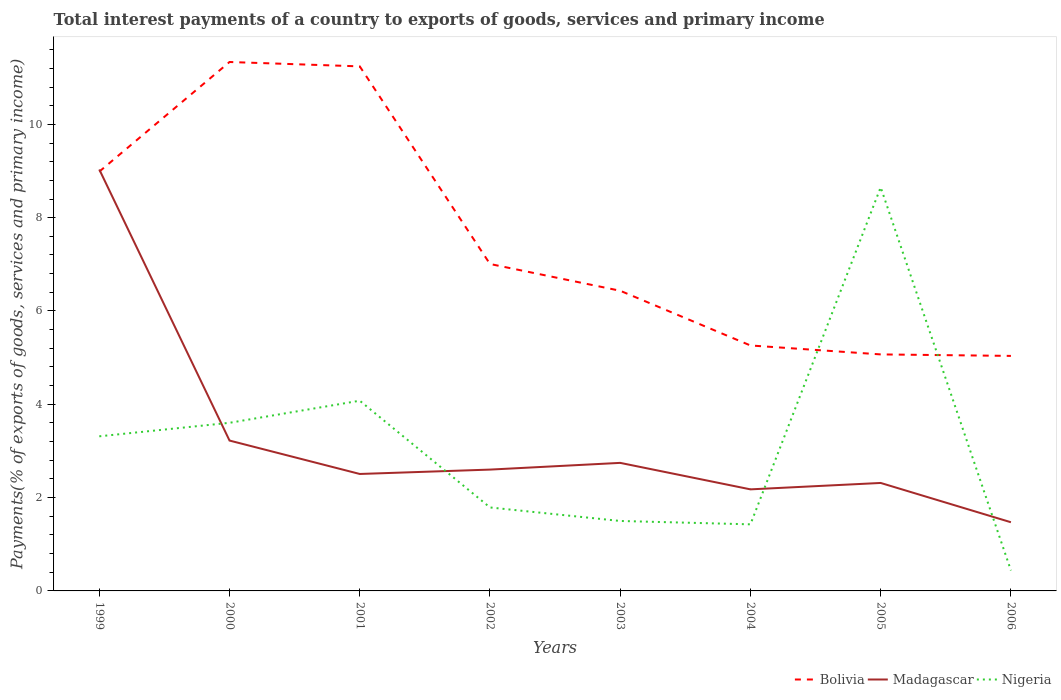Does the line corresponding to Bolivia intersect with the line corresponding to Nigeria?
Your answer should be very brief. Yes. Is the number of lines equal to the number of legend labels?
Your answer should be very brief. Yes. Across all years, what is the maximum total interest payments in Bolivia?
Keep it short and to the point. 5.04. In which year was the total interest payments in Bolivia maximum?
Offer a terse response. 2006. What is the total total interest payments in Bolivia in the graph?
Offer a very short reply. 1.75. What is the difference between the highest and the second highest total interest payments in Bolivia?
Offer a very short reply. 6.3. Is the total interest payments in Nigeria strictly greater than the total interest payments in Madagascar over the years?
Ensure brevity in your answer.  No. What is the difference between two consecutive major ticks on the Y-axis?
Offer a terse response. 2. Are the values on the major ticks of Y-axis written in scientific E-notation?
Make the answer very short. No. Does the graph contain any zero values?
Ensure brevity in your answer.  No. Does the graph contain grids?
Offer a very short reply. No. What is the title of the graph?
Your answer should be compact. Total interest payments of a country to exports of goods, services and primary income. Does "Macedonia" appear as one of the legend labels in the graph?
Provide a short and direct response. No. What is the label or title of the Y-axis?
Offer a very short reply. Payments(% of exports of goods, services and primary income). What is the Payments(% of exports of goods, services and primary income) in Bolivia in 1999?
Your response must be concise. 8.99. What is the Payments(% of exports of goods, services and primary income) of Madagascar in 1999?
Your response must be concise. 9.03. What is the Payments(% of exports of goods, services and primary income) of Nigeria in 1999?
Ensure brevity in your answer.  3.31. What is the Payments(% of exports of goods, services and primary income) in Bolivia in 2000?
Make the answer very short. 11.34. What is the Payments(% of exports of goods, services and primary income) of Madagascar in 2000?
Offer a very short reply. 3.22. What is the Payments(% of exports of goods, services and primary income) of Nigeria in 2000?
Make the answer very short. 3.6. What is the Payments(% of exports of goods, services and primary income) in Bolivia in 2001?
Offer a very short reply. 11.24. What is the Payments(% of exports of goods, services and primary income) of Madagascar in 2001?
Your response must be concise. 2.51. What is the Payments(% of exports of goods, services and primary income) in Nigeria in 2001?
Make the answer very short. 4.08. What is the Payments(% of exports of goods, services and primary income) in Bolivia in 2002?
Offer a very short reply. 7.01. What is the Payments(% of exports of goods, services and primary income) in Madagascar in 2002?
Ensure brevity in your answer.  2.6. What is the Payments(% of exports of goods, services and primary income) of Nigeria in 2002?
Your answer should be compact. 1.79. What is the Payments(% of exports of goods, services and primary income) in Bolivia in 2003?
Make the answer very short. 6.43. What is the Payments(% of exports of goods, services and primary income) of Madagascar in 2003?
Keep it short and to the point. 2.74. What is the Payments(% of exports of goods, services and primary income) in Nigeria in 2003?
Offer a terse response. 1.5. What is the Payments(% of exports of goods, services and primary income) in Bolivia in 2004?
Your response must be concise. 5.26. What is the Payments(% of exports of goods, services and primary income) of Madagascar in 2004?
Provide a succinct answer. 2.18. What is the Payments(% of exports of goods, services and primary income) of Nigeria in 2004?
Your response must be concise. 1.43. What is the Payments(% of exports of goods, services and primary income) of Bolivia in 2005?
Give a very brief answer. 5.07. What is the Payments(% of exports of goods, services and primary income) in Madagascar in 2005?
Your answer should be compact. 2.31. What is the Payments(% of exports of goods, services and primary income) of Nigeria in 2005?
Your answer should be compact. 8.65. What is the Payments(% of exports of goods, services and primary income) of Bolivia in 2006?
Ensure brevity in your answer.  5.04. What is the Payments(% of exports of goods, services and primary income) in Madagascar in 2006?
Offer a very short reply. 1.47. What is the Payments(% of exports of goods, services and primary income) of Nigeria in 2006?
Ensure brevity in your answer.  0.44. Across all years, what is the maximum Payments(% of exports of goods, services and primary income) in Bolivia?
Make the answer very short. 11.34. Across all years, what is the maximum Payments(% of exports of goods, services and primary income) in Madagascar?
Your answer should be very brief. 9.03. Across all years, what is the maximum Payments(% of exports of goods, services and primary income) of Nigeria?
Offer a very short reply. 8.65. Across all years, what is the minimum Payments(% of exports of goods, services and primary income) in Bolivia?
Offer a very short reply. 5.04. Across all years, what is the minimum Payments(% of exports of goods, services and primary income) in Madagascar?
Your answer should be compact. 1.47. Across all years, what is the minimum Payments(% of exports of goods, services and primary income) in Nigeria?
Offer a very short reply. 0.44. What is the total Payments(% of exports of goods, services and primary income) in Bolivia in the graph?
Make the answer very short. 60.37. What is the total Payments(% of exports of goods, services and primary income) in Madagascar in the graph?
Provide a short and direct response. 26.07. What is the total Payments(% of exports of goods, services and primary income) in Nigeria in the graph?
Provide a short and direct response. 24.8. What is the difference between the Payments(% of exports of goods, services and primary income) of Bolivia in 1999 and that in 2000?
Keep it short and to the point. -2.35. What is the difference between the Payments(% of exports of goods, services and primary income) of Madagascar in 1999 and that in 2000?
Offer a very short reply. 5.81. What is the difference between the Payments(% of exports of goods, services and primary income) in Nigeria in 1999 and that in 2000?
Ensure brevity in your answer.  -0.29. What is the difference between the Payments(% of exports of goods, services and primary income) in Bolivia in 1999 and that in 2001?
Provide a succinct answer. -2.26. What is the difference between the Payments(% of exports of goods, services and primary income) of Madagascar in 1999 and that in 2001?
Give a very brief answer. 6.53. What is the difference between the Payments(% of exports of goods, services and primary income) in Nigeria in 1999 and that in 2001?
Provide a succinct answer. -0.76. What is the difference between the Payments(% of exports of goods, services and primary income) of Bolivia in 1999 and that in 2002?
Offer a terse response. 1.98. What is the difference between the Payments(% of exports of goods, services and primary income) in Madagascar in 1999 and that in 2002?
Offer a very short reply. 6.43. What is the difference between the Payments(% of exports of goods, services and primary income) in Nigeria in 1999 and that in 2002?
Offer a terse response. 1.52. What is the difference between the Payments(% of exports of goods, services and primary income) of Bolivia in 1999 and that in 2003?
Offer a terse response. 2.55. What is the difference between the Payments(% of exports of goods, services and primary income) of Madagascar in 1999 and that in 2003?
Ensure brevity in your answer.  6.29. What is the difference between the Payments(% of exports of goods, services and primary income) of Nigeria in 1999 and that in 2003?
Provide a short and direct response. 1.81. What is the difference between the Payments(% of exports of goods, services and primary income) of Bolivia in 1999 and that in 2004?
Ensure brevity in your answer.  3.73. What is the difference between the Payments(% of exports of goods, services and primary income) in Madagascar in 1999 and that in 2004?
Provide a succinct answer. 6.86. What is the difference between the Payments(% of exports of goods, services and primary income) of Nigeria in 1999 and that in 2004?
Your answer should be very brief. 1.89. What is the difference between the Payments(% of exports of goods, services and primary income) of Bolivia in 1999 and that in 2005?
Provide a succinct answer. 3.92. What is the difference between the Payments(% of exports of goods, services and primary income) of Madagascar in 1999 and that in 2005?
Make the answer very short. 6.72. What is the difference between the Payments(% of exports of goods, services and primary income) in Nigeria in 1999 and that in 2005?
Provide a short and direct response. -5.34. What is the difference between the Payments(% of exports of goods, services and primary income) in Bolivia in 1999 and that in 2006?
Keep it short and to the point. 3.95. What is the difference between the Payments(% of exports of goods, services and primary income) in Madagascar in 1999 and that in 2006?
Your answer should be very brief. 7.56. What is the difference between the Payments(% of exports of goods, services and primary income) of Nigeria in 1999 and that in 2006?
Keep it short and to the point. 2.87. What is the difference between the Payments(% of exports of goods, services and primary income) in Bolivia in 2000 and that in 2001?
Offer a very short reply. 0.09. What is the difference between the Payments(% of exports of goods, services and primary income) in Madagascar in 2000 and that in 2001?
Your answer should be very brief. 0.72. What is the difference between the Payments(% of exports of goods, services and primary income) of Nigeria in 2000 and that in 2001?
Make the answer very short. -0.47. What is the difference between the Payments(% of exports of goods, services and primary income) of Bolivia in 2000 and that in 2002?
Your answer should be compact. 4.33. What is the difference between the Payments(% of exports of goods, services and primary income) in Madagascar in 2000 and that in 2002?
Ensure brevity in your answer.  0.62. What is the difference between the Payments(% of exports of goods, services and primary income) of Nigeria in 2000 and that in 2002?
Make the answer very short. 1.81. What is the difference between the Payments(% of exports of goods, services and primary income) of Bolivia in 2000 and that in 2003?
Your answer should be very brief. 4.9. What is the difference between the Payments(% of exports of goods, services and primary income) of Madagascar in 2000 and that in 2003?
Ensure brevity in your answer.  0.48. What is the difference between the Payments(% of exports of goods, services and primary income) of Nigeria in 2000 and that in 2003?
Offer a very short reply. 2.1. What is the difference between the Payments(% of exports of goods, services and primary income) of Bolivia in 2000 and that in 2004?
Provide a short and direct response. 6.08. What is the difference between the Payments(% of exports of goods, services and primary income) in Madagascar in 2000 and that in 2004?
Offer a terse response. 1.05. What is the difference between the Payments(% of exports of goods, services and primary income) in Nigeria in 2000 and that in 2004?
Provide a succinct answer. 2.18. What is the difference between the Payments(% of exports of goods, services and primary income) of Bolivia in 2000 and that in 2005?
Ensure brevity in your answer.  6.27. What is the difference between the Payments(% of exports of goods, services and primary income) in Madagascar in 2000 and that in 2005?
Your answer should be compact. 0.91. What is the difference between the Payments(% of exports of goods, services and primary income) in Nigeria in 2000 and that in 2005?
Provide a succinct answer. -5.05. What is the difference between the Payments(% of exports of goods, services and primary income) in Bolivia in 2000 and that in 2006?
Your answer should be very brief. 6.3. What is the difference between the Payments(% of exports of goods, services and primary income) in Madagascar in 2000 and that in 2006?
Make the answer very short. 1.75. What is the difference between the Payments(% of exports of goods, services and primary income) of Nigeria in 2000 and that in 2006?
Your answer should be compact. 3.16. What is the difference between the Payments(% of exports of goods, services and primary income) of Bolivia in 2001 and that in 2002?
Give a very brief answer. 4.24. What is the difference between the Payments(% of exports of goods, services and primary income) in Madagascar in 2001 and that in 2002?
Provide a short and direct response. -0.09. What is the difference between the Payments(% of exports of goods, services and primary income) in Nigeria in 2001 and that in 2002?
Your response must be concise. 2.29. What is the difference between the Payments(% of exports of goods, services and primary income) in Bolivia in 2001 and that in 2003?
Keep it short and to the point. 4.81. What is the difference between the Payments(% of exports of goods, services and primary income) of Madagascar in 2001 and that in 2003?
Provide a short and direct response. -0.24. What is the difference between the Payments(% of exports of goods, services and primary income) of Nigeria in 2001 and that in 2003?
Your response must be concise. 2.58. What is the difference between the Payments(% of exports of goods, services and primary income) of Bolivia in 2001 and that in 2004?
Keep it short and to the point. 5.98. What is the difference between the Payments(% of exports of goods, services and primary income) in Madagascar in 2001 and that in 2004?
Provide a succinct answer. 0.33. What is the difference between the Payments(% of exports of goods, services and primary income) in Nigeria in 2001 and that in 2004?
Provide a succinct answer. 2.65. What is the difference between the Payments(% of exports of goods, services and primary income) of Bolivia in 2001 and that in 2005?
Your response must be concise. 6.17. What is the difference between the Payments(% of exports of goods, services and primary income) in Madagascar in 2001 and that in 2005?
Your answer should be compact. 0.19. What is the difference between the Payments(% of exports of goods, services and primary income) in Nigeria in 2001 and that in 2005?
Provide a short and direct response. -4.57. What is the difference between the Payments(% of exports of goods, services and primary income) in Bolivia in 2001 and that in 2006?
Ensure brevity in your answer.  6.21. What is the difference between the Payments(% of exports of goods, services and primary income) in Madagascar in 2001 and that in 2006?
Your answer should be very brief. 1.03. What is the difference between the Payments(% of exports of goods, services and primary income) of Nigeria in 2001 and that in 2006?
Your answer should be compact. 3.64. What is the difference between the Payments(% of exports of goods, services and primary income) of Bolivia in 2002 and that in 2003?
Your answer should be compact. 0.57. What is the difference between the Payments(% of exports of goods, services and primary income) of Madagascar in 2002 and that in 2003?
Keep it short and to the point. -0.14. What is the difference between the Payments(% of exports of goods, services and primary income) in Nigeria in 2002 and that in 2003?
Your answer should be compact. 0.29. What is the difference between the Payments(% of exports of goods, services and primary income) in Bolivia in 2002 and that in 2004?
Provide a short and direct response. 1.75. What is the difference between the Payments(% of exports of goods, services and primary income) of Madagascar in 2002 and that in 2004?
Keep it short and to the point. 0.42. What is the difference between the Payments(% of exports of goods, services and primary income) of Nigeria in 2002 and that in 2004?
Provide a short and direct response. 0.36. What is the difference between the Payments(% of exports of goods, services and primary income) in Bolivia in 2002 and that in 2005?
Offer a terse response. 1.94. What is the difference between the Payments(% of exports of goods, services and primary income) of Madagascar in 2002 and that in 2005?
Make the answer very short. 0.29. What is the difference between the Payments(% of exports of goods, services and primary income) in Nigeria in 2002 and that in 2005?
Your answer should be very brief. -6.86. What is the difference between the Payments(% of exports of goods, services and primary income) in Bolivia in 2002 and that in 2006?
Give a very brief answer. 1.97. What is the difference between the Payments(% of exports of goods, services and primary income) of Madagascar in 2002 and that in 2006?
Your answer should be very brief. 1.13. What is the difference between the Payments(% of exports of goods, services and primary income) in Nigeria in 2002 and that in 2006?
Give a very brief answer. 1.35. What is the difference between the Payments(% of exports of goods, services and primary income) in Bolivia in 2003 and that in 2004?
Your answer should be compact. 1.17. What is the difference between the Payments(% of exports of goods, services and primary income) of Madagascar in 2003 and that in 2004?
Ensure brevity in your answer.  0.57. What is the difference between the Payments(% of exports of goods, services and primary income) of Nigeria in 2003 and that in 2004?
Your response must be concise. 0.07. What is the difference between the Payments(% of exports of goods, services and primary income) in Bolivia in 2003 and that in 2005?
Keep it short and to the point. 1.36. What is the difference between the Payments(% of exports of goods, services and primary income) in Madagascar in 2003 and that in 2005?
Your response must be concise. 0.43. What is the difference between the Payments(% of exports of goods, services and primary income) of Nigeria in 2003 and that in 2005?
Your answer should be compact. -7.15. What is the difference between the Payments(% of exports of goods, services and primary income) of Bolivia in 2003 and that in 2006?
Your answer should be compact. 1.4. What is the difference between the Payments(% of exports of goods, services and primary income) of Madagascar in 2003 and that in 2006?
Make the answer very short. 1.27. What is the difference between the Payments(% of exports of goods, services and primary income) in Nigeria in 2003 and that in 2006?
Give a very brief answer. 1.06. What is the difference between the Payments(% of exports of goods, services and primary income) in Bolivia in 2004 and that in 2005?
Ensure brevity in your answer.  0.19. What is the difference between the Payments(% of exports of goods, services and primary income) of Madagascar in 2004 and that in 2005?
Your answer should be compact. -0.14. What is the difference between the Payments(% of exports of goods, services and primary income) of Nigeria in 2004 and that in 2005?
Offer a very short reply. -7.22. What is the difference between the Payments(% of exports of goods, services and primary income) of Bolivia in 2004 and that in 2006?
Ensure brevity in your answer.  0.22. What is the difference between the Payments(% of exports of goods, services and primary income) in Madagascar in 2004 and that in 2006?
Offer a very short reply. 0.7. What is the difference between the Payments(% of exports of goods, services and primary income) of Bolivia in 2005 and that in 2006?
Provide a succinct answer. 0.03. What is the difference between the Payments(% of exports of goods, services and primary income) of Madagascar in 2005 and that in 2006?
Provide a short and direct response. 0.84. What is the difference between the Payments(% of exports of goods, services and primary income) of Nigeria in 2005 and that in 2006?
Provide a succinct answer. 8.21. What is the difference between the Payments(% of exports of goods, services and primary income) of Bolivia in 1999 and the Payments(% of exports of goods, services and primary income) of Madagascar in 2000?
Make the answer very short. 5.76. What is the difference between the Payments(% of exports of goods, services and primary income) in Bolivia in 1999 and the Payments(% of exports of goods, services and primary income) in Nigeria in 2000?
Offer a terse response. 5.38. What is the difference between the Payments(% of exports of goods, services and primary income) in Madagascar in 1999 and the Payments(% of exports of goods, services and primary income) in Nigeria in 2000?
Your answer should be very brief. 5.43. What is the difference between the Payments(% of exports of goods, services and primary income) of Bolivia in 1999 and the Payments(% of exports of goods, services and primary income) of Madagascar in 2001?
Offer a very short reply. 6.48. What is the difference between the Payments(% of exports of goods, services and primary income) of Bolivia in 1999 and the Payments(% of exports of goods, services and primary income) of Nigeria in 2001?
Ensure brevity in your answer.  4.91. What is the difference between the Payments(% of exports of goods, services and primary income) in Madagascar in 1999 and the Payments(% of exports of goods, services and primary income) in Nigeria in 2001?
Make the answer very short. 4.96. What is the difference between the Payments(% of exports of goods, services and primary income) of Bolivia in 1999 and the Payments(% of exports of goods, services and primary income) of Madagascar in 2002?
Your answer should be compact. 6.39. What is the difference between the Payments(% of exports of goods, services and primary income) in Bolivia in 1999 and the Payments(% of exports of goods, services and primary income) in Nigeria in 2002?
Give a very brief answer. 7.2. What is the difference between the Payments(% of exports of goods, services and primary income) of Madagascar in 1999 and the Payments(% of exports of goods, services and primary income) of Nigeria in 2002?
Keep it short and to the point. 7.24. What is the difference between the Payments(% of exports of goods, services and primary income) of Bolivia in 1999 and the Payments(% of exports of goods, services and primary income) of Madagascar in 2003?
Keep it short and to the point. 6.24. What is the difference between the Payments(% of exports of goods, services and primary income) in Bolivia in 1999 and the Payments(% of exports of goods, services and primary income) in Nigeria in 2003?
Ensure brevity in your answer.  7.49. What is the difference between the Payments(% of exports of goods, services and primary income) in Madagascar in 1999 and the Payments(% of exports of goods, services and primary income) in Nigeria in 2003?
Your answer should be compact. 7.53. What is the difference between the Payments(% of exports of goods, services and primary income) in Bolivia in 1999 and the Payments(% of exports of goods, services and primary income) in Madagascar in 2004?
Ensure brevity in your answer.  6.81. What is the difference between the Payments(% of exports of goods, services and primary income) of Bolivia in 1999 and the Payments(% of exports of goods, services and primary income) of Nigeria in 2004?
Keep it short and to the point. 7.56. What is the difference between the Payments(% of exports of goods, services and primary income) of Madagascar in 1999 and the Payments(% of exports of goods, services and primary income) of Nigeria in 2004?
Offer a very short reply. 7.61. What is the difference between the Payments(% of exports of goods, services and primary income) in Bolivia in 1999 and the Payments(% of exports of goods, services and primary income) in Madagascar in 2005?
Your answer should be compact. 6.67. What is the difference between the Payments(% of exports of goods, services and primary income) of Bolivia in 1999 and the Payments(% of exports of goods, services and primary income) of Nigeria in 2005?
Your answer should be compact. 0.34. What is the difference between the Payments(% of exports of goods, services and primary income) in Madagascar in 1999 and the Payments(% of exports of goods, services and primary income) in Nigeria in 2005?
Offer a terse response. 0.38. What is the difference between the Payments(% of exports of goods, services and primary income) in Bolivia in 1999 and the Payments(% of exports of goods, services and primary income) in Madagascar in 2006?
Provide a short and direct response. 7.51. What is the difference between the Payments(% of exports of goods, services and primary income) of Bolivia in 1999 and the Payments(% of exports of goods, services and primary income) of Nigeria in 2006?
Offer a terse response. 8.55. What is the difference between the Payments(% of exports of goods, services and primary income) of Madagascar in 1999 and the Payments(% of exports of goods, services and primary income) of Nigeria in 2006?
Provide a succinct answer. 8.59. What is the difference between the Payments(% of exports of goods, services and primary income) of Bolivia in 2000 and the Payments(% of exports of goods, services and primary income) of Madagascar in 2001?
Provide a short and direct response. 8.83. What is the difference between the Payments(% of exports of goods, services and primary income) in Bolivia in 2000 and the Payments(% of exports of goods, services and primary income) in Nigeria in 2001?
Provide a short and direct response. 7.26. What is the difference between the Payments(% of exports of goods, services and primary income) of Madagascar in 2000 and the Payments(% of exports of goods, services and primary income) of Nigeria in 2001?
Make the answer very short. -0.85. What is the difference between the Payments(% of exports of goods, services and primary income) of Bolivia in 2000 and the Payments(% of exports of goods, services and primary income) of Madagascar in 2002?
Ensure brevity in your answer.  8.74. What is the difference between the Payments(% of exports of goods, services and primary income) in Bolivia in 2000 and the Payments(% of exports of goods, services and primary income) in Nigeria in 2002?
Make the answer very short. 9.55. What is the difference between the Payments(% of exports of goods, services and primary income) of Madagascar in 2000 and the Payments(% of exports of goods, services and primary income) of Nigeria in 2002?
Keep it short and to the point. 1.43. What is the difference between the Payments(% of exports of goods, services and primary income) of Bolivia in 2000 and the Payments(% of exports of goods, services and primary income) of Madagascar in 2003?
Give a very brief answer. 8.59. What is the difference between the Payments(% of exports of goods, services and primary income) in Bolivia in 2000 and the Payments(% of exports of goods, services and primary income) in Nigeria in 2003?
Offer a terse response. 9.84. What is the difference between the Payments(% of exports of goods, services and primary income) in Madagascar in 2000 and the Payments(% of exports of goods, services and primary income) in Nigeria in 2003?
Ensure brevity in your answer.  1.72. What is the difference between the Payments(% of exports of goods, services and primary income) in Bolivia in 2000 and the Payments(% of exports of goods, services and primary income) in Madagascar in 2004?
Keep it short and to the point. 9.16. What is the difference between the Payments(% of exports of goods, services and primary income) of Bolivia in 2000 and the Payments(% of exports of goods, services and primary income) of Nigeria in 2004?
Keep it short and to the point. 9.91. What is the difference between the Payments(% of exports of goods, services and primary income) in Madagascar in 2000 and the Payments(% of exports of goods, services and primary income) in Nigeria in 2004?
Make the answer very short. 1.8. What is the difference between the Payments(% of exports of goods, services and primary income) of Bolivia in 2000 and the Payments(% of exports of goods, services and primary income) of Madagascar in 2005?
Your answer should be very brief. 9.02. What is the difference between the Payments(% of exports of goods, services and primary income) of Bolivia in 2000 and the Payments(% of exports of goods, services and primary income) of Nigeria in 2005?
Your response must be concise. 2.69. What is the difference between the Payments(% of exports of goods, services and primary income) of Madagascar in 2000 and the Payments(% of exports of goods, services and primary income) of Nigeria in 2005?
Your response must be concise. -5.43. What is the difference between the Payments(% of exports of goods, services and primary income) in Bolivia in 2000 and the Payments(% of exports of goods, services and primary income) in Madagascar in 2006?
Make the answer very short. 9.86. What is the difference between the Payments(% of exports of goods, services and primary income) of Bolivia in 2000 and the Payments(% of exports of goods, services and primary income) of Nigeria in 2006?
Your answer should be compact. 10.9. What is the difference between the Payments(% of exports of goods, services and primary income) of Madagascar in 2000 and the Payments(% of exports of goods, services and primary income) of Nigeria in 2006?
Your answer should be very brief. 2.78. What is the difference between the Payments(% of exports of goods, services and primary income) of Bolivia in 2001 and the Payments(% of exports of goods, services and primary income) of Madagascar in 2002?
Your answer should be very brief. 8.64. What is the difference between the Payments(% of exports of goods, services and primary income) of Bolivia in 2001 and the Payments(% of exports of goods, services and primary income) of Nigeria in 2002?
Your answer should be compact. 9.45. What is the difference between the Payments(% of exports of goods, services and primary income) of Madagascar in 2001 and the Payments(% of exports of goods, services and primary income) of Nigeria in 2002?
Make the answer very short. 0.72. What is the difference between the Payments(% of exports of goods, services and primary income) in Bolivia in 2001 and the Payments(% of exports of goods, services and primary income) in Madagascar in 2003?
Offer a very short reply. 8.5. What is the difference between the Payments(% of exports of goods, services and primary income) in Bolivia in 2001 and the Payments(% of exports of goods, services and primary income) in Nigeria in 2003?
Keep it short and to the point. 9.74. What is the difference between the Payments(% of exports of goods, services and primary income) in Madagascar in 2001 and the Payments(% of exports of goods, services and primary income) in Nigeria in 2003?
Give a very brief answer. 1.01. What is the difference between the Payments(% of exports of goods, services and primary income) of Bolivia in 2001 and the Payments(% of exports of goods, services and primary income) of Madagascar in 2004?
Offer a very short reply. 9.07. What is the difference between the Payments(% of exports of goods, services and primary income) in Bolivia in 2001 and the Payments(% of exports of goods, services and primary income) in Nigeria in 2004?
Offer a very short reply. 9.82. What is the difference between the Payments(% of exports of goods, services and primary income) in Madagascar in 2001 and the Payments(% of exports of goods, services and primary income) in Nigeria in 2004?
Make the answer very short. 1.08. What is the difference between the Payments(% of exports of goods, services and primary income) in Bolivia in 2001 and the Payments(% of exports of goods, services and primary income) in Madagascar in 2005?
Offer a terse response. 8.93. What is the difference between the Payments(% of exports of goods, services and primary income) of Bolivia in 2001 and the Payments(% of exports of goods, services and primary income) of Nigeria in 2005?
Your response must be concise. 2.59. What is the difference between the Payments(% of exports of goods, services and primary income) in Madagascar in 2001 and the Payments(% of exports of goods, services and primary income) in Nigeria in 2005?
Your response must be concise. -6.14. What is the difference between the Payments(% of exports of goods, services and primary income) of Bolivia in 2001 and the Payments(% of exports of goods, services and primary income) of Madagascar in 2006?
Give a very brief answer. 9.77. What is the difference between the Payments(% of exports of goods, services and primary income) in Bolivia in 2001 and the Payments(% of exports of goods, services and primary income) in Nigeria in 2006?
Offer a terse response. 10.8. What is the difference between the Payments(% of exports of goods, services and primary income) of Madagascar in 2001 and the Payments(% of exports of goods, services and primary income) of Nigeria in 2006?
Ensure brevity in your answer.  2.07. What is the difference between the Payments(% of exports of goods, services and primary income) of Bolivia in 2002 and the Payments(% of exports of goods, services and primary income) of Madagascar in 2003?
Your answer should be very brief. 4.26. What is the difference between the Payments(% of exports of goods, services and primary income) in Bolivia in 2002 and the Payments(% of exports of goods, services and primary income) in Nigeria in 2003?
Make the answer very short. 5.51. What is the difference between the Payments(% of exports of goods, services and primary income) of Madagascar in 2002 and the Payments(% of exports of goods, services and primary income) of Nigeria in 2003?
Provide a short and direct response. 1.1. What is the difference between the Payments(% of exports of goods, services and primary income) of Bolivia in 2002 and the Payments(% of exports of goods, services and primary income) of Madagascar in 2004?
Provide a succinct answer. 4.83. What is the difference between the Payments(% of exports of goods, services and primary income) in Bolivia in 2002 and the Payments(% of exports of goods, services and primary income) in Nigeria in 2004?
Give a very brief answer. 5.58. What is the difference between the Payments(% of exports of goods, services and primary income) of Madagascar in 2002 and the Payments(% of exports of goods, services and primary income) of Nigeria in 2004?
Your response must be concise. 1.17. What is the difference between the Payments(% of exports of goods, services and primary income) of Bolivia in 2002 and the Payments(% of exports of goods, services and primary income) of Madagascar in 2005?
Provide a succinct answer. 4.69. What is the difference between the Payments(% of exports of goods, services and primary income) in Bolivia in 2002 and the Payments(% of exports of goods, services and primary income) in Nigeria in 2005?
Make the answer very short. -1.64. What is the difference between the Payments(% of exports of goods, services and primary income) of Madagascar in 2002 and the Payments(% of exports of goods, services and primary income) of Nigeria in 2005?
Provide a succinct answer. -6.05. What is the difference between the Payments(% of exports of goods, services and primary income) of Bolivia in 2002 and the Payments(% of exports of goods, services and primary income) of Madagascar in 2006?
Your answer should be very brief. 5.54. What is the difference between the Payments(% of exports of goods, services and primary income) of Bolivia in 2002 and the Payments(% of exports of goods, services and primary income) of Nigeria in 2006?
Offer a terse response. 6.57. What is the difference between the Payments(% of exports of goods, services and primary income) of Madagascar in 2002 and the Payments(% of exports of goods, services and primary income) of Nigeria in 2006?
Provide a succinct answer. 2.16. What is the difference between the Payments(% of exports of goods, services and primary income) of Bolivia in 2003 and the Payments(% of exports of goods, services and primary income) of Madagascar in 2004?
Offer a terse response. 4.26. What is the difference between the Payments(% of exports of goods, services and primary income) in Bolivia in 2003 and the Payments(% of exports of goods, services and primary income) in Nigeria in 2004?
Make the answer very short. 5.01. What is the difference between the Payments(% of exports of goods, services and primary income) of Madagascar in 2003 and the Payments(% of exports of goods, services and primary income) of Nigeria in 2004?
Your answer should be compact. 1.32. What is the difference between the Payments(% of exports of goods, services and primary income) of Bolivia in 2003 and the Payments(% of exports of goods, services and primary income) of Madagascar in 2005?
Offer a very short reply. 4.12. What is the difference between the Payments(% of exports of goods, services and primary income) in Bolivia in 2003 and the Payments(% of exports of goods, services and primary income) in Nigeria in 2005?
Provide a succinct answer. -2.22. What is the difference between the Payments(% of exports of goods, services and primary income) in Madagascar in 2003 and the Payments(% of exports of goods, services and primary income) in Nigeria in 2005?
Your answer should be compact. -5.91. What is the difference between the Payments(% of exports of goods, services and primary income) of Bolivia in 2003 and the Payments(% of exports of goods, services and primary income) of Madagascar in 2006?
Your answer should be very brief. 4.96. What is the difference between the Payments(% of exports of goods, services and primary income) of Bolivia in 2003 and the Payments(% of exports of goods, services and primary income) of Nigeria in 2006?
Your answer should be very brief. 5.99. What is the difference between the Payments(% of exports of goods, services and primary income) in Madagascar in 2003 and the Payments(% of exports of goods, services and primary income) in Nigeria in 2006?
Make the answer very short. 2.31. What is the difference between the Payments(% of exports of goods, services and primary income) in Bolivia in 2004 and the Payments(% of exports of goods, services and primary income) in Madagascar in 2005?
Your response must be concise. 2.95. What is the difference between the Payments(% of exports of goods, services and primary income) in Bolivia in 2004 and the Payments(% of exports of goods, services and primary income) in Nigeria in 2005?
Make the answer very short. -3.39. What is the difference between the Payments(% of exports of goods, services and primary income) of Madagascar in 2004 and the Payments(% of exports of goods, services and primary income) of Nigeria in 2005?
Offer a very short reply. -6.47. What is the difference between the Payments(% of exports of goods, services and primary income) of Bolivia in 2004 and the Payments(% of exports of goods, services and primary income) of Madagascar in 2006?
Your response must be concise. 3.79. What is the difference between the Payments(% of exports of goods, services and primary income) in Bolivia in 2004 and the Payments(% of exports of goods, services and primary income) in Nigeria in 2006?
Keep it short and to the point. 4.82. What is the difference between the Payments(% of exports of goods, services and primary income) in Madagascar in 2004 and the Payments(% of exports of goods, services and primary income) in Nigeria in 2006?
Your response must be concise. 1.74. What is the difference between the Payments(% of exports of goods, services and primary income) of Bolivia in 2005 and the Payments(% of exports of goods, services and primary income) of Madagascar in 2006?
Provide a succinct answer. 3.6. What is the difference between the Payments(% of exports of goods, services and primary income) of Bolivia in 2005 and the Payments(% of exports of goods, services and primary income) of Nigeria in 2006?
Offer a very short reply. 4.63. What is the difference between the Payments(% of exports of goods, services and primary income) in Madagascar in 2005 and the Payments(% of exports of goods, services and primary income) in Nigeria in 2006?
Your response must be concise. 1.88. What is the average Payments(% of exports of goods, services and primary income) of Bolivia per year?
Your response must be concise. 7.55. What is the average Payments(% of exports of goods, services and primary income) of Madagascar per year?
Make the answer very short. 3.26. What is the average Payments(% of exports of goods, services and primary income) of Nigeria per year?
Ensure brevity in your answer.  3.1. In the year 1999, what is the difference between the Payments(% of exports of goods, services and primary income) in Bolivia and Payments(% of exports of goods, services and primary income) in Madagascar?
Give a very brief answer. -0.05. In the year 1999, what is the difference between the Payments(% of exports of goods, services and primary income) of Bolivia and Payments(% of exports of goods, services and primary income) of Nigeria?
Ensure brevity in your answer.  5.67. In the year 1999, what is the difference between the Payments(% of exports of goods, services and primary income) of Madagascar and Payments(% of exports of goods, services and primary income) of Nigeria?
Provide a succinct answer. 5.72. In the year 2000, what is the difference between the Payments(% of exports of goods, services and primary income) in Bolivia and Payments(% of exports of goods, services and primary income) in Madagascar?
Give a very brief answer. 8.11. In the year 2000, what is the difference between the Payments(% of exports of goods, services and primary income) of Bolivia and Payments(% of exports of goods, services and primary income) of Nigeria?
Make the answer very short. 7.73. In the year 2000, what is the difference between the Payments(% of exports of goods, services and primary income) in Madagascar and Payments(% of exports of goods, services and primary income) in Nigeria?
Provide a short and direct response. -0.38. In the year 2001, what is the difference between the Payments(% of exports of goods, services and primary income) in Bolivia and Payments(% of exports of goods, services and primary income) in Madagascar?
Your response must be concise. 8.74. In the year 2001, what is the difference between the Payments(% of exports of goods, services and primary income) of Bolivia and Payments(% of exports of goods, services and primary income) of Nigeria?
Make the answer very short. 7.17. In the year 2001, what is the difference between the Payments(% of exports of goods, services and primary income) in Madagascar and Payments(% of exports of goods, services and primary income) in Nigeria?
Provide a succinct answer. -1.57. In the year 2002, what is the difference between the Payments(% of exports of goods, services and primary income) of Bolivia and Payments(% of exports of goods, services and primary income) of Madagascar?
Your answer should be very brief. 4.41. In the year 2002, what is the difference between the Payments(% of exports of goods, services and primary income) of Bolivia and Payments(% of exports of goods, services and primary income) of Nigeria?
Ensure brevity in your answer.  5.22. In the year 2002, what is the difference between the Payments(% of exports of goods, services and primary income) in Madagascar and Payments(% of exports of goods, services and primary income) in Nigeria?
Your answer should be compact. 0.81. In the year 2003, what is the difference between the Payments(% of exports of goods, services and primary income) of Bolivia and Payments(% of exports of goods, services and primary income) of Madagascar?
Provide a succinct answer. 3.69. In the year 2003, what is the difference between the Payments(% of exports of goods, services and primary income) in Bolivia and Payments(% of exports of goods, services and primary income) in Nigeria?
Provide a succinct answer. 4.93. In the year 2003, what is the difference between the Payments(% of exports of goods, services and primary income) in Madagascar and Payments(% of exports of goods, services and primary income) in Nigeria?
Keep it short and to the point. 1.25. In the year 2004, what is the difference between the Payments(% of exports of goods, services and primary income) of Bolivia and Payments(% of exports of goods, services and primary income) of Madagascar?
Offer a very short reply. 3.08. In the year 2004, what is the difference between the Payments(% of exports of goods, services and primary income) of Bolivia and Payments(% of exports of goods, services and primary income) of Nigeria?
Ensure brevity in your answer.  3.83. In the year 2004, what is the difference between the Payments(% of exports of goods, services and primary income) of Madagascar and Payments(% of exports of goods, services and primary income) of Nigeria?
Provide a succinct answer. 0.75. In the year 2005, what is the difference between the Payments(% of exports of goods, services and primary income) in Bolivia and Payments(% of exports of goods, services and primary income) in Madagascar?
Keep it short and to the point. 2.76. In the year 2005, what is the difference between the Payments(% of exports of goods, services and primary income) of Bolivia and Payments(% of exports of goods, services and primary income) of Nigeria?
Your answer should be very brief. -3.58. In the year 2005, what is the difference between the Payments(% of exports of goods, services and primary income) of Madagascar and Payments(% of exports of goods, services and primary income) of Nigeria?
Offer a terse response. -6.34. In the year 2006, what is the difference between the Payments(% of exports of goods, services and primary income) in Bolivia and Payments(% of exports of goods, services and primary income) in Madagascar?
Your answer should be very brief. 3.56. In the year 2006, what is the difference between the Payments(% of exports of goods, services and primary income) in Bolivia and Payments(% of exports of goods, services and primary income) in Nigeria?
Keep it short and to the point. 4.6. In the year 2006, what is the difference between the Payments(% of exports of goods, services and primary income) of Madagascar and Payments(% of exports of goods, services and primary income) of Nigeria?
Keep it short and to the point. 1.03. What is the ratio of the Payments(% of exports of goods, services and primary income) of Bolivia in 1999 to that in 2000?
Your answer should be very brief. 0.79. What is the ratio of the Payments(% of exports of goods, services and primary income) in Madagascar in 1999 to that in 2000?
Keep it short and to the point. 2.8. What is the ratio of the Payments(% of exports of goods, services and primary income) in Nigeria in 1999 to that in 2000?
Keep it short and to the point. 0.92. What is the ratio of the Payments(% of exports of goods, services and primary income) in Bolivia in 1999 to that in 2001?
Your response must be concise. 0.8. What is the ratio of the Payments(% of exports of goods, services and primary income) of Madagascar in 1999 to that in 2001?
Keep it short and to the point. 3.6. What is the ratio of the Payments(% of exports of goods, services and primary income) of Nigeria in 1999 to that in 2001?
Offer a very short reply. 0.81. What is the ratio of the Payments(% of exports of goods, services and primary income) in Bolivia in 1999 to that in 2002?
Provide a succinct answer. 1.28. What is the ratio of the Payments(% of exports of goods, services and primary income) in Madagascar in 1999 to that in 2002?
Give a very brief answer. 3.47. What is the ratio of the Payments(% of exports of goods, services and primary income) of Nigeria in 1999 to that in 2002?
Provide a short and direct response. 1.85. What is the ratio of the Payments(% of exports of goods, services and primary income) of Bolivia in 1999 to that in 2003?
Provide a short and direct response. 1.4. What is the ratio of the Payments(% of exports of goods, services and primary income) in Madagascar in 1999 to that in 2003?
Provide a short and direct response. 3.29. What is the ratio of the Payments(% of exports of goods, services and primary income) in Nigeria in 1999 to that in 2003?
Offer a terse response. 2.21. What is the ratio of the Payments(% of exports of goods, services and primary income) of Bolivia in 1999 to that in 2004?
Provide a short and direct response. 1.71. What is the ratio of the Payments(% of exports of goods, services and primary income) of Madagascar in 1999 to that in 2004?
Give a very brief answer. 4.15. What is the ratio of the Payments(% of exports of goods, services and primary income) in Nigeria in 1999 to that in 2004?
Provide a short and direct response. 2.32. What is the ratio of the Payments(% of exports of goods, services and primary income) of Bolivia in 1999 to that in 2005?
Make the answer very short. 1.77. What is the ratio of the Payments(% of exports of goods, services and primary income) of Madagascar in 1999 to that in 2005?
Provide a short and direct response. 3.9. What is the ratio of the Payments(% of exports of goods, services and primary income) of Nigeria in 1999 to that in 2005?
Your answer should be very brief. 0.38. What is the ratio of the Payments(% of exports of goods, services and primary income) of Bolivia in 1999 to that in 2006?
Your response must be concise. 1.78. What is the ratio of the Payments(% of exports of goods, services and primary income) of Madagascar in 1999 to that in 2006?
Ensure brevity in your answer.  6.14. What is the ratio of the Payments(% of exports of goods, services and primary income) in Nigeria in 1999 to that in 2006?
Your answer should be very brief. 7.55. What is the ratio of the Payments(% of exports of goods, services and primary income) of Bolivia in 2000 to that in 2001?
Provide a short and direct response. 1.01. What is the ratio of the Payments(% of exports of goods, services and primary income) in Nigeria in 2000 to that in 2001?
Make the answer very short. 0.88. What is the ratio of the Payments(% of exports of goods, services and primary income) in Bolivia in 2000 to that in 2002?
Give a very brief answer. 1.62. What is the ratio of the Payments(% of exports of goods, services and primary income) of Madagascar in 2000 to that in 2002?
Provide a short and direct response. 1.24. What is the ratio of the Payments(% of exports of goods, services and primary income) in Nigeria in 2000 to that in 2002?
Your response must be concise. 2.01. What is the ratio of the Payments(% of exports of goods, services and primary income) of Bolivia in 2000 to that in 2003?
Provide a short and direct response. 1.76. What is the ratio of the Payments(% of exports of goods, services and primary income) in Madagascar in 2000 to that in 2003?
Your answer should be very brief. 1.17. What is the ratio of the Payments(% of exports of goods, services and primary income) of Nigeria in 2000 to that in 2003?
Ensure brevity in your answer.  2.4. What is the ratio of the Payments(% of exports of goods, services and primary income) in Bolivia in 2000 to that in 2004?
Offer a very short reply. 2.15. What is the ratio of the Payments(% of exports of goods, services and primary income) in Madagascar in 2000 to that in 2004?
Offer a terse response. 1.48. What is the ratio of the Payments(% of exports of goods, services and primary income) of Nigeria in 2000 to that in 2004?
Give a very brief answer. 2.52. What is the ratio of the Payments(% of exports of goods, services and primary income) in Bolivia in 2000 to that in 2005?
Provide a succinct answer. 2.24. What is the ratio of the Payments(% of exports of goods, services and primary income) in Madagascar in 2000 to that in 2005?
Ensure brevity in your answer.  1.39. What is the ratio of the Payments(% of exports of goods, services and primary income) in Nigeria in 2000 to that in 2005?
Your response must be concise. 0.42. What is the ratio of the Payments(% of exports of goods, services and primary income) of Bolivia in 2000 to that in 2006?
Make the answer very short. 2.25. What is the ratio of the Payments(% of exports of goods, services and primary income) of Madagascar in 2000 to that in 2006?
Make the answer very short. 2.19. What is the ratio of the Payments(% of exports of goods, services and primary income) of Nigeria in 2000 to that in 2006?
Your answer should be very brief. 8.21. What is the ratio of the Payments(% of exports of goods, services and primary income) of Bolivia in 2001 to that in 2002?
Provide a short and direct response. 1.6. What is the ratio of the Payments(% of exports of goods, services and primary income) in Madagascar in 2001 to that in 2002?
Ensure brevity in your answer.  0.96. What is the ratio of the Payments(% of exports of goods, services and primary income) of Nigeria in 2001 to that in 2002?
Make the answer very short. 2.28. What is the ratio of the Payments(% of exports of goods, services and primary income) in Bolivia in 2001 to that in 2003?
Your answer should be very brief. 1.75. What is the ratio of the Payments(% of exports of goods, services and primary income) in Madagascar in 2001 to that in 2003?
Provide a short and direct response. 0.91. What is the ratio of the Payments(% of exports of goods, services and primary income) in Nigeria in 2001 to that in 2003?
Offer a very short reply. 2.72. What is the ratio of the Payments(% of exports of goods, services and primary income) of Bolivia in 2001 to that in 2004?
Ensure brevity in your answer.  2.14. What is the ratio of the Payments(% of exports of goods, services and primary income) of Madagascar in 2001 to that in 2004?
Make the answer very short. 1.15. What is the ratio of the Payments(% of exports of goods, services and primary income) in Nigeria in 2001 to that in 2004?
Ensure brevity in your answer.  2.86. What is the ratio of the Payments(% of exports of goods, services and primary income) of Bolivia in 2001 to that in 2005?
Keep it short and to the point. 2.22. What is the ratio of the Payments(% of exports of goods, services and primary income) in Madagascar in 2001 to that in 2005?
Provide a succinct answer. 1.08. What is the ratio of the Payments(% of exports of goods, services and primary income) in Nigeria in 2001 to that in 2005?
Offer a very short reply. 0.47. What is the ratio of the Payments(% of exports of goods, services and primary income) of Bolivia in 2001 to that in 2006?
Provide a short and direct response. 2.23. What is the ratio of the Payments(% of exports of goods, services and primary income) of Madagascar in 2001 to that in 2006?
Your answer should be compact. 1.7. What is the ratio of the Payments(% of exports of goods, services and primary income) in Nigeria in 2001 to that in 2006?
Make the answer very short. 9.28. What is the ratio of the Payments(% of exports of goods, services and primary income) of Bolivia in 2002 to that in 2003?
Provide a succinct answer. 1.09. What is the ratio of the Payments(% of exports of goods, services and primary income) in Madagascar in 2002 to that in 2003?
Your response must be concise. 0.95. What is the ratio of the Payments(% of exports of goods, services and primary income) of Nigeria in 2002 to that in 2003?
Make the answer very short. 1.19. What is the ratio of the Payments(% of exports of goods, services and primary income) of Bolivia in 2002 to that in 2004?
Your response must be concise. 1.33. What is the ratio of the Payments(% of exports of goods, services and primary income) in Madagascar in 2002 to that in 2004?
Keep it short and to the point. 1.19. What is the ratio of the Payments(% of exports of goods, services and primary income) of Nigeria in 2002 to that in 2004?
Keep it short and to the point. 1.25. What is the ratio of the Payments(% of exports of goods, services and primary income) in Bolivia in 2002 to that in 2005?
Keep it short and to the point. 1.38. What is the ratio of the Payments(% of exports of goods, services and primary income) of Madagascar in 2002 to that in 2005?
Your answer should be very brief. 1.12. What is the ratio of the Payments(% of exports of goods, services and primary income) in Nigeria in 2002 to that in 2005?
Offer a very short reply. 0.21. What is the ratio of the Payments(% of exports of goods, services and primary income) in Bolivia in 2002 to that in 2006?
Your answer should be very brief. 1.39. What is the ratio of the Payments(% of exports of goods, services and primary income) in Madagascar in 2002 to that in 2006?
Your answer should be very brief. 1.77. What is the ratio of the Payments(% of exports of goods, services and primary income) in Nigeria in 2002 to that in 2006?
Your answer should be compact. 4.07. What is the ratio of the Payments(% of exports of goods, services and primary income) in Bolivia in 2003 to that in 2004?
Ensure brevity in your answer.  1.22. What is the ratio of the Payments(% of exports of goods, services and primary income) of Madagascar in 2003 to that in 2004?
Ensure brevity in your answer.  1.26. What is the ratio of the Payments(% of exports of goods, services and primary income) of Nigeria in 2003 to that in 2004?
Your response must be concise. 1.05. What is the ratio of the Payments(% of exports of goods, services and primary income) in Bolivia in 2003 to that in 2005?
Your answer should be compact. 1.27. What is the ratio of the Payments(% of exports of goods, services and primary income) of Madagascar in 2003 to that in 2005?
Give a very brief answer. 1.19. What is the ratio of the Payments(% of exports of goods, services and primary income) of Nigeria in 2003 to that in 2005?
Ensure brevity in your answer.  0.17. What is the ratio of the Payments(% of exports of goods, services and primary income) in Bolivia in 2003 to that in 2006?
Give a very brief answer. 1.28. What is the ratio of the Payments(% of exports of goods, services and primary income) in Madagascar in 2003 to that in 2006?
Provide a short and direct response. 1.86. What is the ratio of the Payments(% of exports of goods, services and primary income) in Nigeria in 2003 to that in 2006?
Keep it short and to the point. 3.41. What is the ratio of the Payments(% of exports of goods, services and primary income) of Bolivia in 2004 to that in 2005?
Offer a very short reply. 1.04. What is the ratio of the Payments(% of exports of goods, services and primary income) in Madagascar in 2004 to that in 2005?
Your answer should be compact. 0.94. What is the ratio of the Payments(% of exports of goods, services and primary income) of Nigeria in 2004 to that in 2005?
Ensure brevity in your answer.  0.17. What is the ratio of the Payments(% of exports of goods, services and primary income) in Bolivia in 2004 to that in 2006?
Offer a very short reply. 1.04. What is the ratio of the Payments(% of exports of goods, services and primary income) of Madagascar in 2004 to that in 2006?
Provide a short and direct response. 1.48. What is the ratio of the Payments(% of exports of goods, services and primary income) of Nigeria in 2004 to that in 2006?
Provide a succinct answer. 3.25. What is the ratio of the Payments(% of exports of goods, services and primary income) of Bolivia in 2005 to that in 2006?
Offer a very short reply. 1.01. What is the ratio of the Payments(% of exports of goods, services and primary income) of Madagascar in 2005 to that in 2006?
Ensure brevity in your answer.  1.57. What is the ratio of the Payments(% of exports of goods, services and primary income) of Nigeria in 2005 to that in 2006?
Offer a very short reply. 19.7. What is the difference between the highest and the second highest Payments(% of exports of goods, services and primary income) in Bolivia?
Keep it short and to the point. 0.09. What is the difference between the highest and the second highest Payments(% of exports of goods, services and primary income) in Madagascar?
Give a very brief answer. 5.81. What is the difference between the highest and the second highest Payments(% of exports of goods, services and primary income) of Nigeria?
Offer a terse response. 4.57. What is the difference between the highest and the lowest Payments(% of exports of goods, services and primary income) of Bolivia?
Offer a very short reply. 6.3. What is the difference between the highest and the lowest Payments(% of exports of goods, services and primary income) of Madagascar?
Your answer should be very brief. 7.56. What is the difference between the highest and the lowest Payments(% of exports of goods, services and primary income) of Nigeria?
Provide a short and direct response. 8.21. 